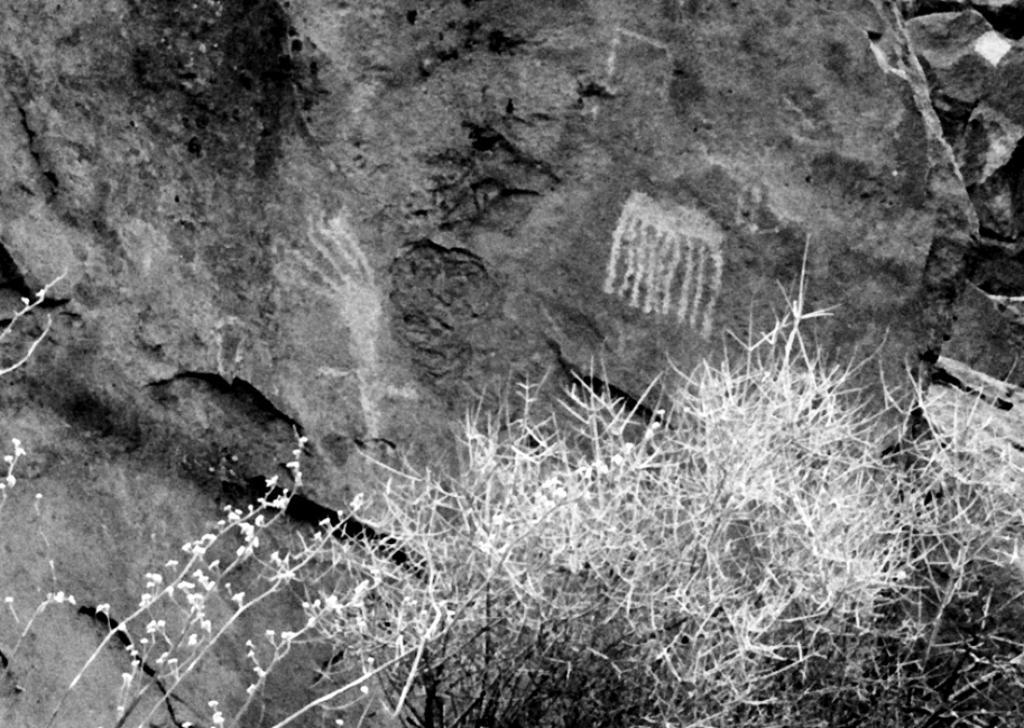In one or two sentences, can you explain what this image depicts? In this picture we can see few plants and rocks. 